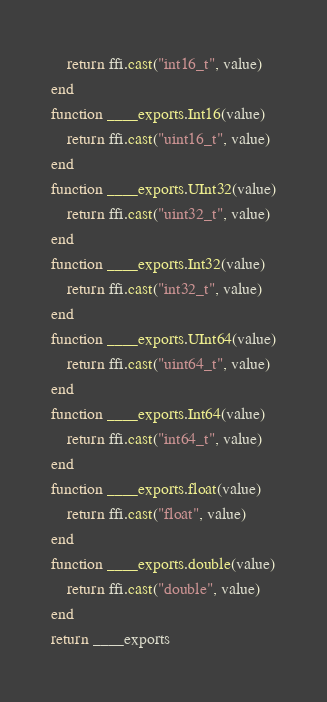Convert code to text. <code><loc_0><loc_0><loc_500><loc_500><_Lua_>    return ffi.cast("int16_t", value)
end
function ____exports.Int16(value)
    return ffi.cast("uint16_t", value)
end
function ____exports.UInt32(value)
    return ffi.cast("uint32_t", value)
end
function ____exports.Int32(value)
    return ffi.cast("int32_t", value)
end
function ____exports.UInt64(value)
    return ffi.cast("uint64_t", value)
end
function ____exports.Int64(value)
    return ffi.cast("int64_t", value)
end
function ____exports.float(value)
    return ffi.cast("float", value)
end
function ____exports.double(value)
    return ffi.cast("double", value)
end
return ____exports
</code> 